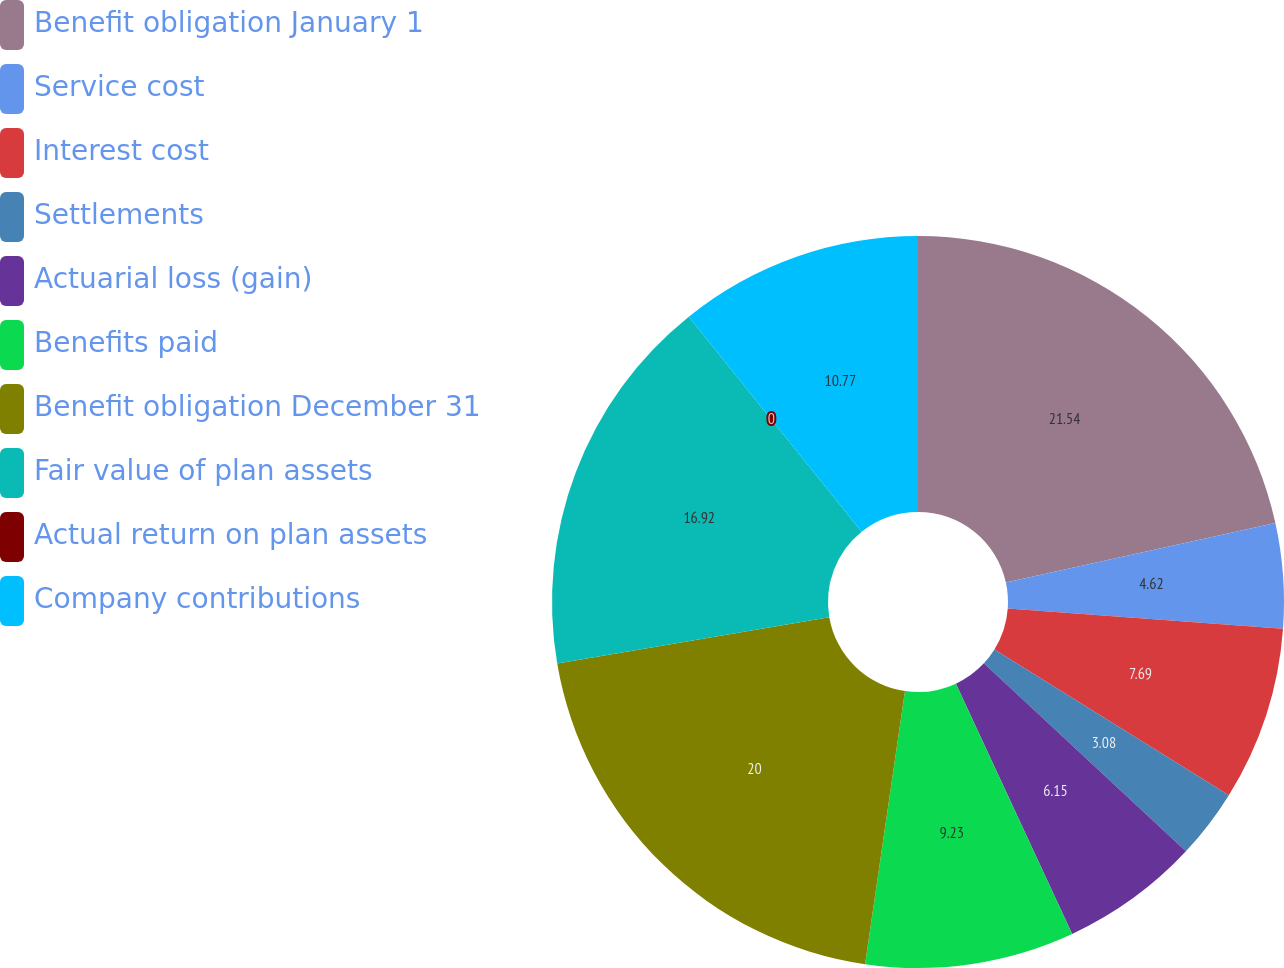Convert chart to OTSL. <chart><loc_0><loc_0><loc_500><loc_500><pie_chart><fcel>Benefit obligation January 1<fcel>Service cost<fcel>Interest cost<fcel>Settlements<fcel>Actuarial loss (gain)<fcel>Benefits paid<fcel>Benefit obligation December 31<fcel>Fair value of plan assets<fcel>Actual return on plan assets<fcel>Company contributions<nl><fcel>21.54%<fcel>4.62%<fcel>7.69%<fcel>3.08%<fcel>6.15%<fcel>9.23%<fcel>20.0%<fcel>16.92%<fcel>0.0%<fcel>10.77%<nl></chart> 